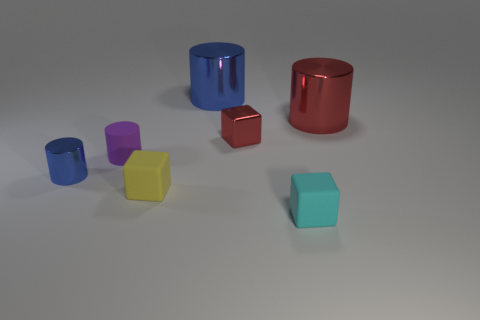There is a small blue metal cylinder; are there any purple cylinders on the left side of it?
Your answer should be compact. No. Are there an equal number of small blue metal things to the right of the tiny purple cylinder and big red metal balls?
Provide a short and direct response. Yes. There is a cyan rubber thing that is the same size as the yellow object; what is its shape?
Provide a succinct answer. Cube. What material is the tiny cyan object?
Keep it short and to the point. Rubber. The shiny cylinder that is both right of the purple thing and to the left of the big red cylinder is what color?
Offer a very short reply. Blue. Are there an equal number of metal blocks to the right of the cyan matte block and blue cylinders behind the tiny red object?
Your answer should be compact. No. There is a block that is made of the same material as the big blue cylinder; what is its color?
Provide a succinct answer. Red. Do the small matte cylinder and the tiny matte object on the right side of the red metal block have the same color?
Keep it short and to the point. No. Is there a big red thing on the left side of the cube that is in front of the small yellow block on the left side of the big red shiny thing?
Provide a succinct answer. No. What is the shape of the tiny cyan object that is made of the same material as the yellow thing?
Ensure brevity in your answer.  Cube. 